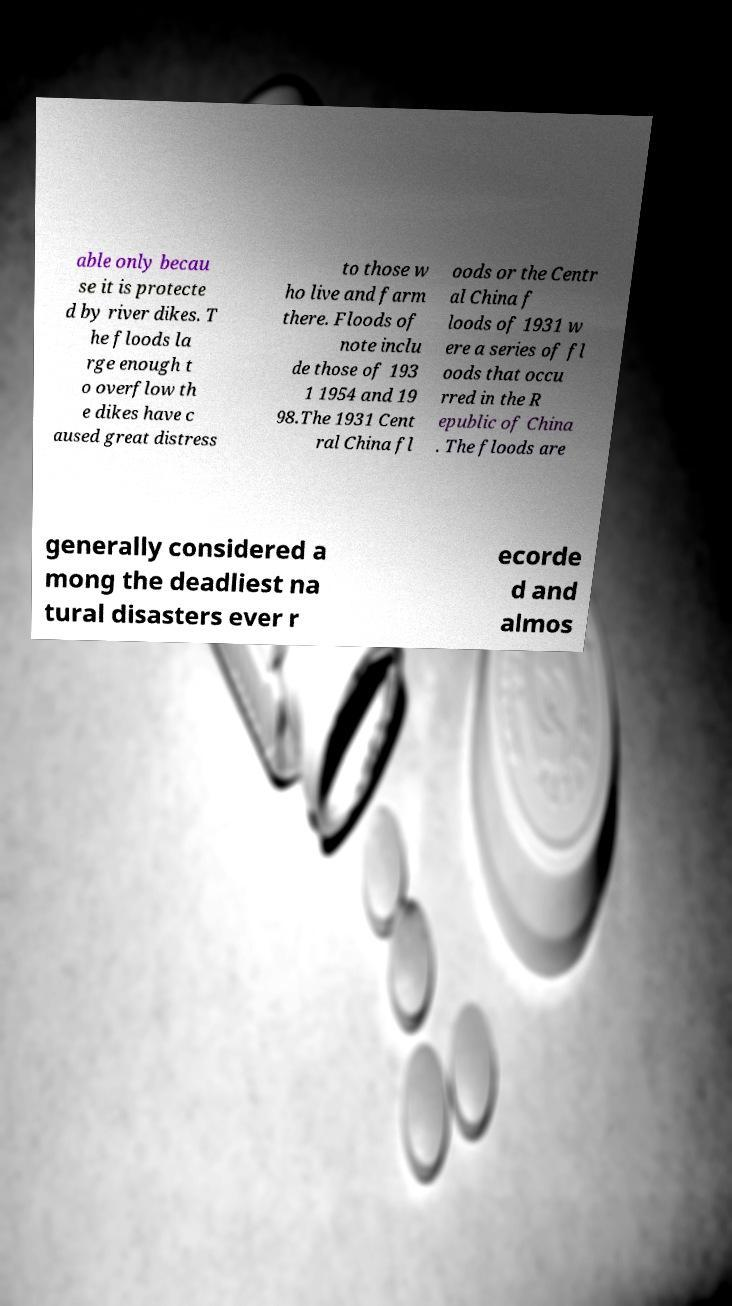Can you accurately transcribe the text from the provided image for me? able only becau se it is protecte d by river dikes. T he floods la rge enough t o overflow th e dikes have c aused great distress to those w ho live and farm there. Floods of note inclu de those of 193 1 1954 and 19 98.The 1931 Cent ral China fl oods or the Centr al China f loods of 1931 w ere a series of fl oods that occu rred in the R epublic of China . The floods are generally considered a mong the deadliest na tural disasters ever r ecorde d and almos 